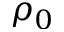Convert formula to latex. <formula><loc_0><loc_0><loc_500><loc_500>\rho _ { 0 }</formula> 